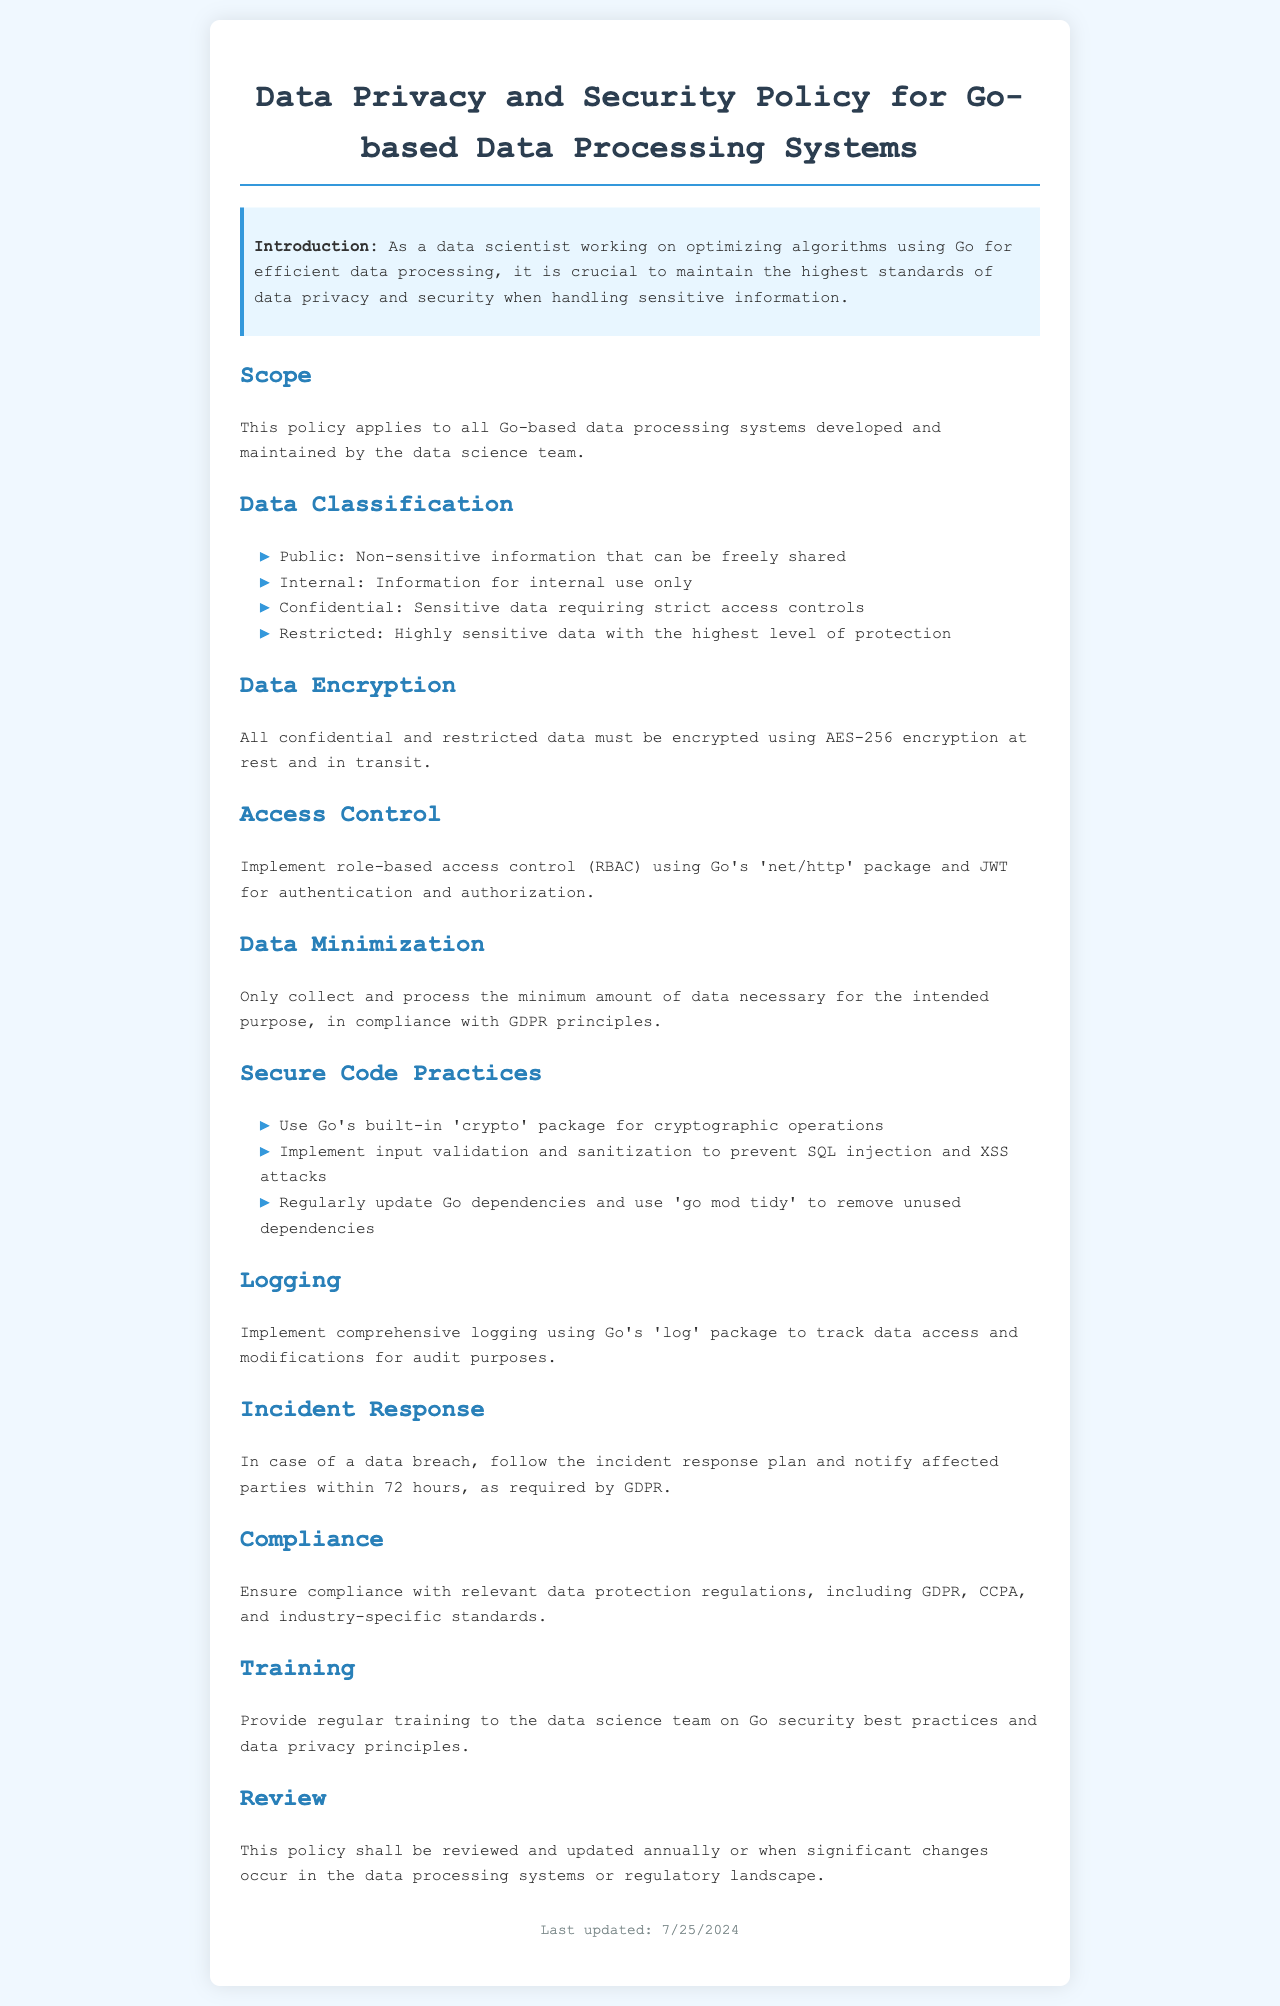What is the highest level of data classification? The highest level of data classification mentioned in the document is "Restricted."
Answer: Restricted What type of encryption should be used for confidential data? The document states that all confidential data must be encrypted using "AES-256 encryption."
Answer: AES-256 encryption What is the role of the 'net/http' package in the Go-based systems? The document specifies that the 'net/http' package is used for implementing "role-based access control (RBAC)."
Answer: role-based access control (RBAC) How often should the data privacy policy be reviewed? According to the document, the policy shall be reviewed and updated "annually."
Answer: annually What should happen in case of a data breach? The document outlines that in the case of a data breach, parties must be notified "within 72 hours."
Answer: within 72 hours What is a key practice for secure code mentioned in the policy? The policy recommends using Go's built-in "crypto" package for cryptographic operations.
Answer: crypto package How is data minimization aligned with legal regulations? The policy states that data minimization complies with "GDPR principles."
Answer: GDPR principles What is essential for comprehensive logging in Go-based systems? The document emphasizes implementation of logging using Go's "log" package."
Answer: log package Which standards must be ensured for compliance? The document mentions compliance with "GDPR, CCPA, and industry-specific standards."
Answer: GDPR, CCPA, and industry-specific standards 